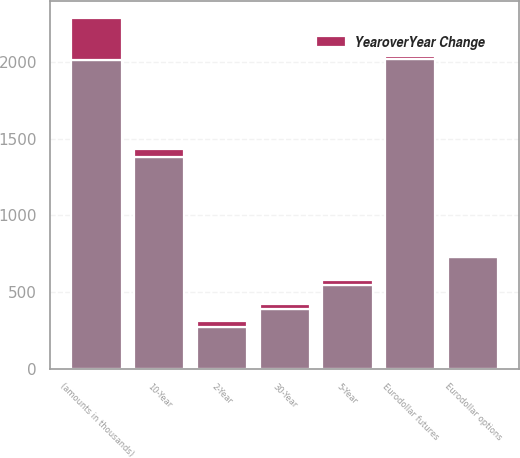<chart> <loc_0><loc_0><loc_500><loc_500><stacked_bar_chart><ecel><fcel>(amounts in thousands)<fcel>Eurodollar futures<fcel>Eurodollar options<fcel>10-Year<fcel>5-Year<fcel>30-Year<fcel>2-Year<nl><fcel>nan<fcel>2010<fcel>2020<fcel>726<fcel>1380<fcel>546<fcel>388<fcel>274<nl><fcel>YearoverYear Change<fcel>274<fcel>16<fcel>14<fcel>51<fcel>33<fcel>33<fcel>37<nl></chart> 